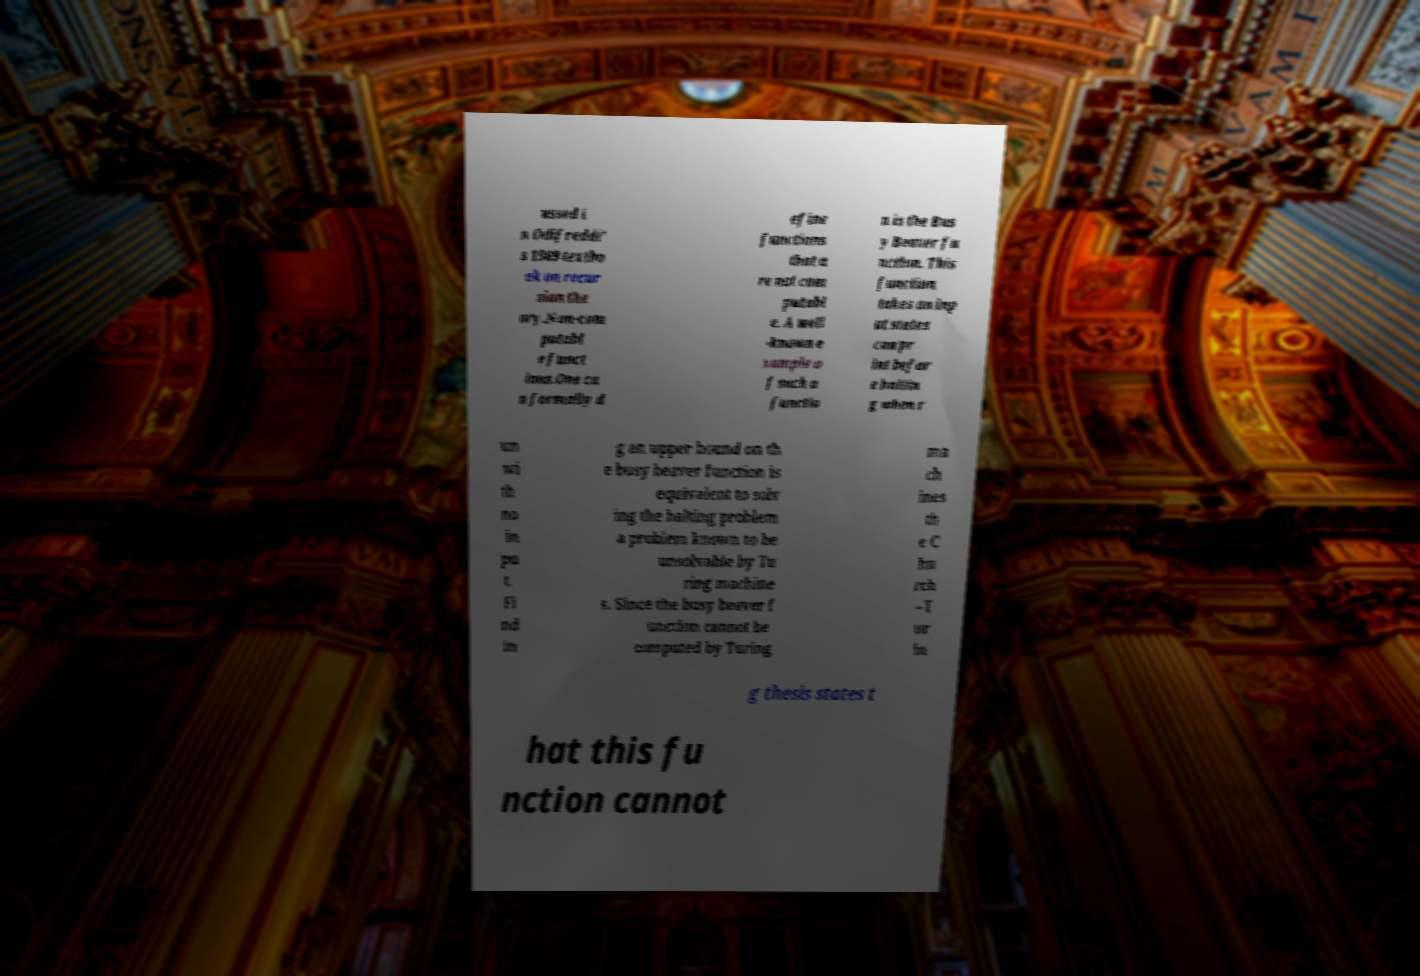Could you assist in decoding the text presented in this image and type it out clearly? ussed i n Odifreddi' s 1989 textbo ok on recur sion the ory.Non-com putabl e funct ions.One ca n formally d efine functions that a re not com putabl e. A well -known e xample o f such a functio n is the Bus y Beaver fu nction. This function takes an inp ut states can pr int befor e haltin g when r un wi th no in pu t. Fi nd in g an upper bound on th e busy beaver function is equivalent to solv ing the halting problem a problem known to be unsolvable by Tu ring machine s. Since the busy beaver f unction cannot be computed by Turing ma ch ines th e C hu rch –T ur in g thesis states t hat this fu nction cannot 